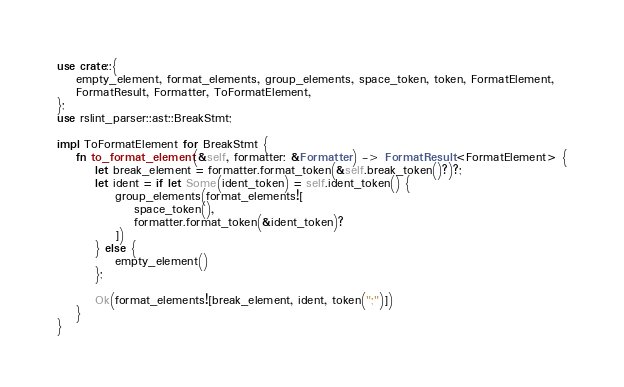<code> <loc_0><loc_0><loc_500><loc_500><_Rust_>use crate::{
	empty_element, format_elements, group_elements, space_token, token, FormatElement,
	FormatResult, Formatter, ToFormatElement,
};
use rslint_parser::ast::BreakStmt;

impl ToFormatElement for BreakStmt {
	fn to_format_element(&self, formatter: &Formatter) -> FormatResult<FormatElement> {
		let break_element = formatter.format_token(&self.break_token()?)?;
		let ident = if let Some(ident_token) = self.ident_token() {
			group_elements(format_elements![
				space_token(),
				formatter.format_token(&ident_token)?
			])
		} else {
			empty_element()
		};

		Ok(format_elements![break_element, ident, token(";")])
	}
}
</code> 